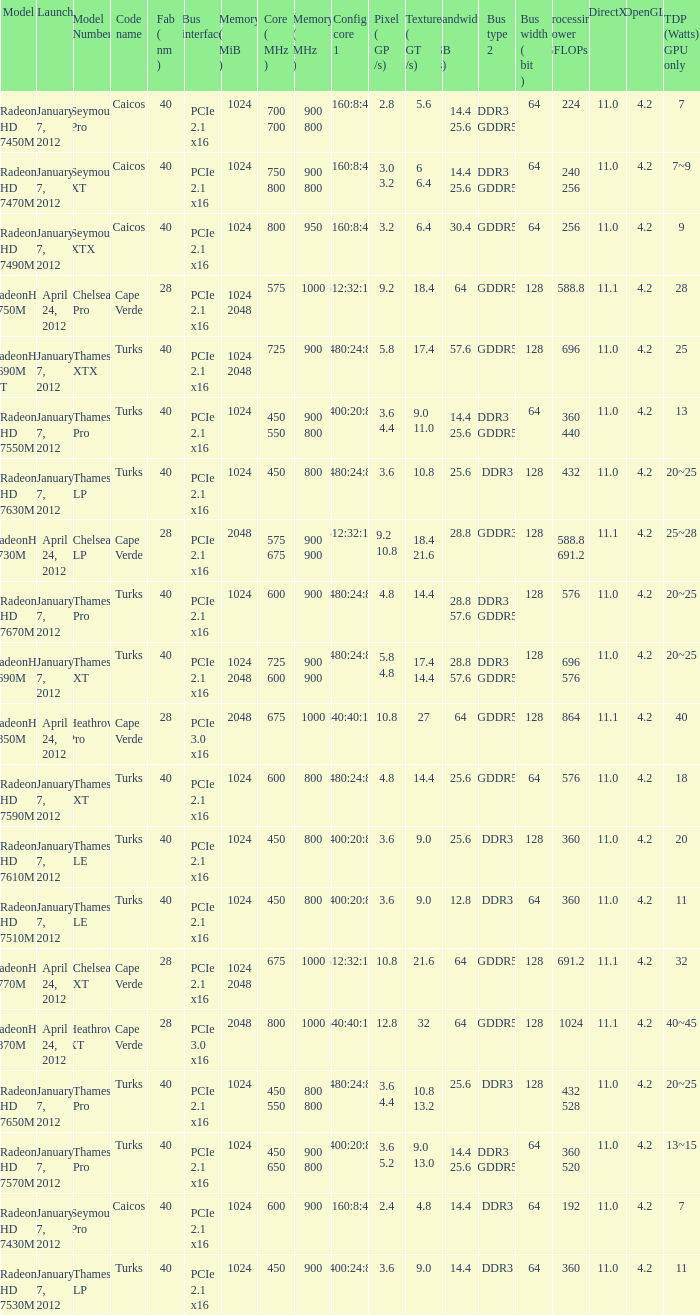Give me the full table as a dictionary. {'header': ['Model', 'Launch', 'Model Number', 'Code name', 'Fab ( nm )', 'Bus interface', 'Memory ( MiB )', 'Core ( MHz )', 'Memory ( MHz )', 'Config core 1', 'Pixel ( GP /s)', 'Texture ( GT /s)', 'Bandwidth ( GB /s)', 'Bus type 2', 'Bus width ( bit )', 'Processing Power GFLOPs', 'DirectX', 'OpenGL', 'TDP (Watts) GPU only'], 'rows': [['Radeon HD 7450M', 'January 7, 2012', 'Seymour Pro', 'Caicos', '40', 'PCIe 2.1 x16', '1024', '700 700', '900 800', '160:8:4', '2.8', '5.6', '14.4 25.6', 'DDR3 GDDR5', '64', '224', '11.0', '4.2', '7'], ['Radeon HD 7470M', 'January 7, 2012', 'Seymour XT', 'Caicos', '40', 'PCIe 2.1 x16', '1024', '750 800', '900 800', '160:8:4', '3.0 3.2', '6 6.4', '14.4 25.6', 'DDR3 GDDR5', '64', '240 256', '11.0', '4.2', '7~9'], ['Radeon HD 7490M', 'January 7, 2012', 'Seymour XTX', 'Caicos', '40', 'PCIe 2.1 x16', '1024', '800', '950', '160:8:4', '3.2', '6.4', '30.4', 'GDDR5', '64', '256', '11.0', '4.2', '9'], ['RadeonHD 7750M', 'April 24, 2012', 'Chelsea Pro', 'Cape Verde', '28', 'PCIe 2.1 x16', '1024 2048', '575', '1000', '512:32:16', '9.2', '18.4', '64', 'GDDR5', '128', '588.8', '11.1', '4.2', '28'], ['RadeonHD 7690M XT', 'January 7, 2012', 'Thames XTX', 'Turks', '40', 'PCIe 2.1 x16', '1024 2048', '725', '900', '480:24:8', '5.8', '17.4', '57.6', 'GDDR5', '128', '696', '11.0', '4.2', '25'], ['Radeon HD 7550M', 'January 7, 2012', 'Thames Pro', 'Turks', '40', 'PCIe 2.1 x16', '1024', '450 550', '900 800', '400:20:8', '3.6 4.4', '9.0 11.0', '14.4 25.6', 'DDR3 GDDR5', '64', '360 440', '11.0', '4.2', '13'], ['Radeon HD 7630M', 'January 7, 2012', 'Thames LP', 'Turks', '40', 'PCIe 2.1 x16', '1024', '450', '800', '480:24:8', '3.6', '10.8', '25.6', 'DDR3', '128', '432', '11.0', '4.2', '20~25'], ['RadeonHD 7730M', 'April 24, 2012', 'Chelsea LP', 'Cape Verde', '28', 'PCIe 2.1 x16', '2048', '575 675', '900 900', '512:32:16', '9.2 10.8', '18.4 21.6', '28.8', 'GDDR3', '128', '588.8 691.2', '11.1', '4.2', '25~28'], ['Radeon HD 7670M', 'January 7, 2012', 'Thames Pro', 'Turks', '40', 'PCIe 2.1 x16', '1024', '600', '900', '480:24:8', '4.8', '14.4', '28.8 57.6', 'DDR3 GDDR5', '128', '576', '11.0', '4.2', '20~25'], ['RadeonHD 7690M', 'January 7, 2012', 'Thames XT', 'Turks', '40', 'PCIe 2.1 x16', '1024 2048', '725 600', '900 900', '480:24:8', '5.8 4.8', '17.4 14.4', '28.8 57.6', 'DDR3 GDDR5', '128', '696 576', '11.0', '4.2', '20~25'], ['RadeonHD 7850M', 'April 24, 2012', 'Heathrow Pro', 'Cape Verde', '28', 'PCIe 3.0 x16', '2048', '675', '1000', '640:40:16', '10.8', '27', '64', 'GDDR5', '128', '864', '11.1', '4.2', '40'], ['Radeon HD 7590M', 'January 7, 2012', 'Thames XT', 'Turks', '40', 'PCIe 2.1 x16', '1024', '600', '800', '480:24:8', '4.8', '14.4', '25.6', 'GDDR5', '64', '576', '11.0', '4.2', '18'], ['Radeon HD 7610M', 'January 7, 2012', 'Thames LE', 'Turks', '40', 'PCIe 2.1 x16', '1024', '450', '800', '400:20:8', '3.6', '9.0', '25.6', 'DDR3', '128', '360', '11.0', '4.2', '20'], ['Radeon HD 7510M', 'January 7, 2012', 'Thames LE', 'Turks', '40', 'PCIe 2.1 x16', '1024', '450', '800', '400:20:8', '3.6', '9.0', '12.8', 'DDR3', '64', '360', '11.0', '4.2', '11'], ['RadeonHD 7770M', 'April 24, 2012', 'Chelsea XT', 'Cape Verde', '28', 'PCIe 2.1 x16', '1024 2048', '675', '1000', '512:32:16', '10.8', '21.6', '64', 'GDDR5', '128', '691.2', '11.1', '4.2', '32'], ['RadeonHD 7870M', 'April 24, 2012', 'Heathrow XT', 'Cape Verde', '28', 'PCIe 3.0 x16', '2048', '800', '1000', '640:40:16', '12.8', '32', '64', 'GDDR5', '128', '1024', '11.1', '4.2', '40~45'], ['Radeon HD 7650M', 'January 7, 2012', 'Thames Pro', 'Turks', '40', 'PCIe 2.1 x16', '1024', '450 550', '800 800', '480:24:8', '3.6 4.4', '10.8 13.2', '25.6', 'DDR3', '128', '432 528', '11.0', '4.2', '20~25'], ['Radeon HD 7570M', 'January 7, 2012', 'Thames Pro', 'Turks', '40', 'PCIe 2.1 x16', '1024', '450 650', '900 800', '400:20:8', '3.6 5.2', '9.0 13.0', '14.4 25.6', 'DDR3 GDDR5', '64', '360 520', '11.0', '4.2', '13~15'], ['Radeon HD 7430M', 'January 7, 2012', 'Seymour Pro', 'Caicos', '40', 'PCIe 2.1 x16', '1024', '600', '900', '160:8:4', '2.4', '4.8', '14.4', 'DDR3', '64', '192', '11.0', '4.2', '7'], ['Radeon HD 7530M', 'January 7, 2012', 'Thames LP', 'Turks', '40', 'PCIe 2.1 x16', '1024', '450', '900', '400:24:8', '3.6', '9.0', '14.4', 'DDR3', '64', '360', '11.0', '4.2', '11']]} What is the config core 1 of the model with a processing power GFLOPs of 432? 480:24:8. 